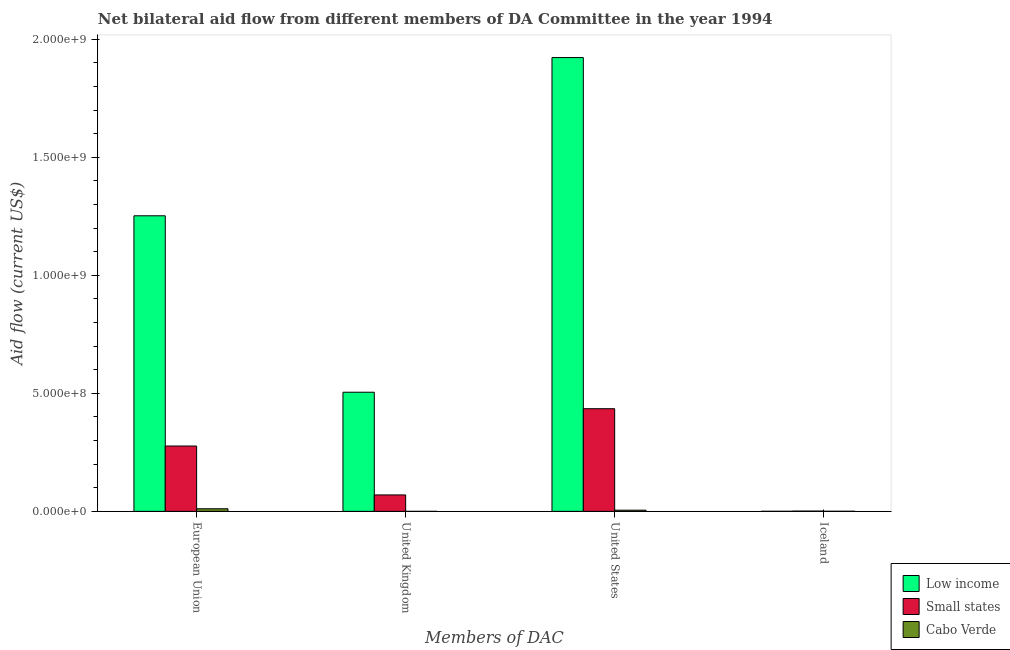How many different coloured bars are there?
Offer a very short reply. 3. How many bars are there on the 2nd tick from the left?
Offer a terse response. 3. What is the label of the 4th group of bars from the left?
Your answer should be compact. Iceland. What is the amount of aid given by us in Small states?
Provide a short and direct response. 4.35e+08. Across all countries, what is the maximum amount of aid given by us?
Make the answer very short. 1.92e+09. Across all countries, what is the minimum amount of aid given by us?
Your answer should be very brief. 5.00e+06. In which country was the amount of aid given by iceland minimum?
Keep it short and to the point. Low income. What is the total amount of aid given by eu in the graph?
Provide a short and direct response. 1.54e+09. What is the difference between the amount of aid given by us in Low income and that in Small states?
Offer a terse response. 1.49e+09. What is the difference between the amount of aid given by us in Low income and the amount of aid given by uk in Cabo Verde?
Your response must be concise. 1.92e+09. What is the average amount of aid given by uk per country?
Ensure brevity in your answer.  1.92e+08. What is the difference between the amount of aid given by us and amount of aid given by eu in Small states?
Make the answer very short. 1.58e+08. In how many countries, is the amount of aid given by eu greater than 500000000 US$?
Your answer should be compact. 1. What is the ratio of the amount of aid given by uk in Cabo Verde to that in Low income?
Offer a terse response. 1.980707905005249e-5. Is the difference between the amount of aid given by eu in Low income and Small states greater than the difference between the amount of aid given by us in Low income and Small states?
Give a very brief answer. No. What is the difference between the highest and the second highest amount of aid given by us?
Give a very brief answer. 1.49e+09. What is the difference between the highest and the lowest amount of aid given by eu?
Keep it short and to the point. 1.24e+09. Is the sum of the amount of aid given by uk in Low income and Cabo Verde greater than the maximum amount of aid given by iceland across all countries?
Provide a succinct answer. Yes. Is it the case that in every country, the sum of the amount of aid given by us and amount of aid given by eu is greater than the sum of amount of aid given by iceland and amount of aid given by uk?
Your answer should be compact. No. What does the 3rd bar from the left in United States represents?
Your answer should be very brief. Cabo Verde. Are all the bars in the graph horizontal?
Make the answer very short. No. Where does the legend appear in the graph?
Provide a short and direct response. Bottom right. What is the title of the graph?
Offer a very short reply. Net bilateral aid flow from different members of DA Committee in the year 1994. Does "Latin America(developing only)" appear as one of the legend labels in the graph?
Offer a terse response. No. What is the label or title of the X-axis?
Keep it short and to the point. Members of DAC. What is the label or title of the Y-axis?
Give a very brief answer. Aid flow (current US$). What is the Aid flow (current US$) of Low income in European Union?
Offer a very short reply. 1.25e+09. What is the Aid flow (current US$) of Small states in European Union?
Your response must be concise. 2.77e+08. What is the Aid flow (current US$) of Cabo Verde in European Union?
Keep it short and to the point. 1.10e+07. What is the Aid flow (current US$) in Low income in United Kingdom?
Give a very brief answer. 5.05e+08. What is the Aid flow (current US$) in Small states in United Kingdom?
Provide a short and direct response. 6.97e+07. What is the Aid flow (current US$) in Cabo Verde in United Kingdom?
Offer a terse response. 10000. What is the Aid flow (current US$) of Low income in United States?
Your answer should be very brief. 1.92e+09. What is the Aid flow (current US$) of Small states in United States?
Your response must be concise. 4.35e+08. What is the Aid flow (current US$) of Small states in Iceland?
Your response must be concise. 1.27e+06. What is the Aid flow (current US$) in Cabo Verde in Iceland?
Provide a succinct answer. 4.70e+05. Across all Members of DAC, what is the maximum Aid flow (current US$) in Low income?
Offer a terse response. 1.92e+09. Across all Members of DAC, what is the maximum Aid flow (current US$) of Small states?
Your answer should be very brief. 4.35e+08. Across all Members of DAC, what is the maximum Aid flow (current US$) in Cabo Verde?
Your answer should be compact. 1.10e+07. Across all Members of DAC, what is the minimum Aid flow (current US$) of Small states?
Provide a succinct answer. 1.27e+06. What is the total Aid flow (current US$) of Low income in the graph?
Make the answer very short. 3.68e+09. What is the total Aid flow (current US$) in Small states in the graph?
Offer a terse response. 7.83e+08. What is the total Aid flow (current US$) of Cabo Verde in the graph?
Offer a very short reply. 1.64e+07. What is the difference between the Aid flow (current US$) of Low income in European Union and that in United Kingdom?
Offer a terse response. 7.48e+08. What is the difference between the Aid flow (current US$) of Small states in European Union and that in United Kingdom?
Your answer should be very brief. 2.07e+08. What is the difference between the Aid flow (current US$) of Cabo Verde in European Union and that in United Kingdom?
Ensure brevity in your answer.  1.10e+07. What is the difference between the Aid flow (current US$) in Low income in European Union and that in United States?
Make the answer very short. -6.70e+08. What is the difference between the Aid flow (current US$) in Small states in European Union and that in United States?
Offer a very short reply. -1.58e+08. What is the difference between the Aid flow (current US$) of Cabo Verde in European Union and that in United States?
Ensure brevity in your answer.  5.96e+06. What is the difference between the Aid flow (current US$) of Low income in European Union and that in Iceland?
Make the answer very short. 1.25e+09. What is the difference between the Aid flow (current US$) in Small states in European Union and that in Iceland?
Give a very brief answer. 2.76e+08. What is the difference between the Aid flow (current US$) of Cabo Verde in European Union and that in Iceland?
Your answer should be compact. 1.05e+07. What is the difference between the Aid flow (current US$) of Low income in United Kingdom and that in United States?
Your answer should be compact. -1.42e+09. What is the difference between the Aid flow (current US$) in Small states in United Kingdom and that in United States?
Provide a short and direct response. -3.65e+08. What is the difference between the Aid flow (current US$) in Cabo Verde in United Kingdom and that in United States?
Ensure brevity in your answer.  -4.99e+06. What is the difference between the Aid flow (current US$) in Low income in United Kingdom and that in Iceland?
Offer a terse response. 5.05e+08. What is the difference between the Aid flow (current US$) of Small states in United Kingdom and that in Iceland?
Keep it short and to the point. 6.84e+07. What is the difference between the Aid flow (current US$) in Cabo Verde in United Kingdom and that in Iceland?
Offer a terse response. -4.60e+05. What is the difference between the Aid flow (current US$) of Low income in United States and that in Iceland?
Provide a short and direct response. 1.92e+09. What is the difference between the Aid flow (current US$) of Small states in United States and that in Iceland?
Keep it short and to the point. 4.34e+08. What is the difference between the Aid flow (current US$) in Cabo Verde in United States and that in Iceland?
Make the answer very short. 4.53e+06. What is the difference between the Aid flow (current US$) in Low income in European Union and the Aid flow (current US$) in Small states in United Kingdom?
Your answer should be compact. 1.18e+09. What is the difference between the Aid flow (current US$) in Low income in European Union and the Aid flow (current US$) in Cabo Verde in United Kingdom?
Your answer should be very brief. 1.25e+09. What is the difference between the Aid flow (current US$) of Small states in European Union and the Aid flow (current US$) of Cabo Verde in United Kingdom?
Give a very brief answer. 2.77e+08. What is the difference between the Aid flow (current US$) of Low income in European Union and the Aid flow (current US$) of Small states in United States?
Offer a very short reply. 8.18e+08. What is the difference between the Aid flow (current US$) in Low income in European Union and the Aid flow (current US$) in Cabo Verde in United States?
Ensure brevity in your answer.  1.25e+09. What is the difference between the Aid flow (current US$) of Small states in European Union and the Aid flow (current US$) of Cabo Verde in United States?
Offer a terse response. 2.72e+08. What is the difference between the Aid flow (current US$) in Low income in European Union and the Aid flow (current US$) in Small states in Iceland?
Give a very brief answer. 1.25e+09. What is the difference between the Aid flow (current US$) in Low income in European Union and the Aid flow (current US$) in Cabo Verde in Iceland?
Your response must be concise. 1.25e+09. What is the difference between the Aid flow (current US$) of Small states in European Union and the Aid flow (current US$) of Cabo Verde in Iceland?
Your answer should be compact. 2.76e+08. What is the difference between the Aid flow (current US$) in Low income in United Kingdom and the Aid flow (current US$) in Small states in United States?
Your answer should be very brief. 6.99e+07. What is the difference between the Aid flow (current US$) of Low income in United Kingdom and the Aid flow (current US$) of Cabo Verde in United States?
Your answer should be very brief. 5.00e+08. What is the difference between the Aid flow (current US$) of Small states in United Kingdom and the Aid flow (current US$) of Cabo Verde in United States?
Keep it short and to the point. 6.47e+07. What is the difference between the Aid flow (current US$) in Low income in United Kingdom and the Aid flow (current US$) in Small states in Iceland?
Offer a very short reply. 5.04e+08. What is the difference between the Aid flow (current US$) of Low income in United Kingdom and the Aid flow (current US$) of Cabo Verde in Iceland?
Keep it short and to the point. 5.04e+08. What is the difference between the Aid flow (current US$) of Small states in United Kingdom and the Aid flow (current US$) of Cabo Verde in Iceland?
Make the answer very short. 6.92e+07. What is the difference between the Aid flow (current US$) of Low income in United States and the Aid flow (current US$) of Small states in Iceland?
Provide a short and direct response. 1.92e+09. What is the difference between the Aid flow (current US$) of Low income in United States and the Aid flow (current US$) of Cabo Verde in Iceland?
Offer a very short reply. 1.92e+09. What is the difference between the Aid flow (current US$) of Small states in United States and the Aid flow (current US$) of Cabo Verde in Iceland?
Make the answer very short. 4.35e+08. What is the average Aid flow (current US$) of Low income per Members of DAC?
Ensure brevity in your answer.  9.20e+08. What is the average Aid flow (current US$) in Small states per Members of DAC?
Make the answer very short. 1.96e+08. What is the average Aid flow (current US$) in Cabo Verde per Members of DAC?
Your answer should be very brief. 4.11e+06. What is the difference between the Aid flow (current US$) of Low income and Aid flow (current US$) of Small states in European Union?
Your answer should be very brief. 9.76e+08. What is the difference between the Aid flow (current US$) of Low income and Aid flow (current US$) of Cabo Verde in European Union?
Provide a succinct answer. 1.24e+09. What is the difference between the Aid flow (current US$) in Small states and Aid flow (current US$) in Cabo Verde in European Union?
Keep it short and to the point. 2.66e+08. What is the difference between the Aid flow (current US$) of Low income and Aid flow (current US$) of Small states in United Kingdom?
Keep it short and to the point. 4.35e+08. What is the difference between the Aid flow (current US$) in Low income and Aid flow (current US$) in Cabo Verde in United Kingdom?
Offer a terse response. 5.05e+08. What is the difference between the Aid flow (current US$) of Small states and Aid flow (current US$) of Cabo Verde in United Kingdom?
Offer a terse response. 6.96e+07. What is the difference between the Aid flow (current US$) in Low income and Aid flow (current US$) in Small states in United States?
Ensure brevity in your answer.  1.49e+09. What is the difference between the Aid flow (current US$) in Low income and Aid flow (current US$) in Cabo Verde in United States?
Keep it short and to the point. 1.92e+09. What is the difference between the Aid flow (current US$) in Small states and Aid flow (current US$) in Cabo Verde in United States?
Ensure brevity in your answer.  4.30e+08. What is the difference between the Aid flow (current US$) of Low income and Aid flow (current US$) of Small states in Iceland?
Your answer should be very brief. -9.30e+05. What is the difference between the Aid flow (current US$) of Low income and Aid flow (current US$) of Cabo Verde in Iceland?
Make the answer very short. -1.30e+05. What is the ratio of the Aid flow (current US$) of Low income in European Union to that in United Kingdom?
Make the answer very short. 2.48. What is the ratio of the Aid flow (current US$) in Small states in European Union to that in United Kingdom?
Keep it short and to the point. 3.97. What is the ratio of the Aid flow (current US$) in Cabo Verde in European Union to that in United Kingdom?
Provide a short and direct response. 1096. What is the ratio of the Aid flow (current US$) in Low income in European Union to that in United States?
Give a very brief answer. 0.65. What is the ratio of the Aid flow (current US$) in Small states in European Union to that in United States?
Your response must be concise. 0.64. What is the ratio of the Aid flow (current US$) in Cabo Verde in European Union to that in United States?
Ensure brevity in your answer.  2.19. What is the ratio of the Aid flow (current US$) of Low income in European Union to that in Iceland?
Ensure brevity in your answer.  3683.94. What is the ratio of the Aid flow (current US$) in Small states in European Union to that in Iceland?
Keep it short and to the point. 218.02. What is the ratio of the Aid flow (current US$) of Cabo Verde in European Union to that in Iceland?
Provide a short and direct response. 23.32. What is the ratio of the Aid flow (current US$) in Low income in United Kingdom to that in United States?
Offer a very short reply. 0.26. What is the ratio of the Aid flow (current US$) in Small states in United Kingdom to that in United States?
Offer a terse response. 0.16. What is the ratio of the Aid flow (current US$) in Cabo Verde in United Kingdom to that in United States?
Offer a very short reply. 0. What is the ratio of the Aid flow (current US$) in Low income in United Kingdom to that in Iceland?
Offer a terse response. 1484.91. What is the ratio of the Aid flow (current US$) in Small states in United Kingdom to that in Iceland?
Make the answer very short. 54.85. What is the ratio of the Aid flow (current US$) in Cabo Verde in United Kingdom to that in Iceland?
Provide a short and direct response. 0.02. What is the ratio of the Aid flow (current US$) of Low income in United States to that in Iceland?
Provide a succinct answer. 5655.88. What is the ratio of the Aid flow (current US$) in Small states in United States to that in Iceland?
Give a very brief answer. 342.52. What is the ratio of the Aid flow (current US$) of Cabo Verde in United States to that in Iceland?
Your answer should be very brief. 10.64. What is the difference between the highest and the second highest Aid flow (current US$) in Low income?
Make the answer very short. 6.70e+08. What is the difference between the highest and the second highest Aid flow (current US$) of Small states?
Your answer should be very brief. 1.58e+08. What is the difference between the highest and the second highest Aid flow (current US$) in Cabo Verde?
Ensure brevity in your answer.  5.96e+06. What is the difference between the highest and the lowest Aid flow (current US$) in Low income?
Give a very brief answer. 1.92e+09. What is the difference between the highest and the lowest Aid flow (current US$) of Small states?
Your answer should be compact. 4.34e+08. What is the difference between the highest and the lowest Aid flow (current US$) of Cabo Verde?
Make the answer very short. 1.10e+07. 